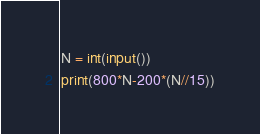<code> <loc_0><loc_0><loc_500><loc_500><_Python_>N = int(input())
print(800*N-200*(N//15))</code> 